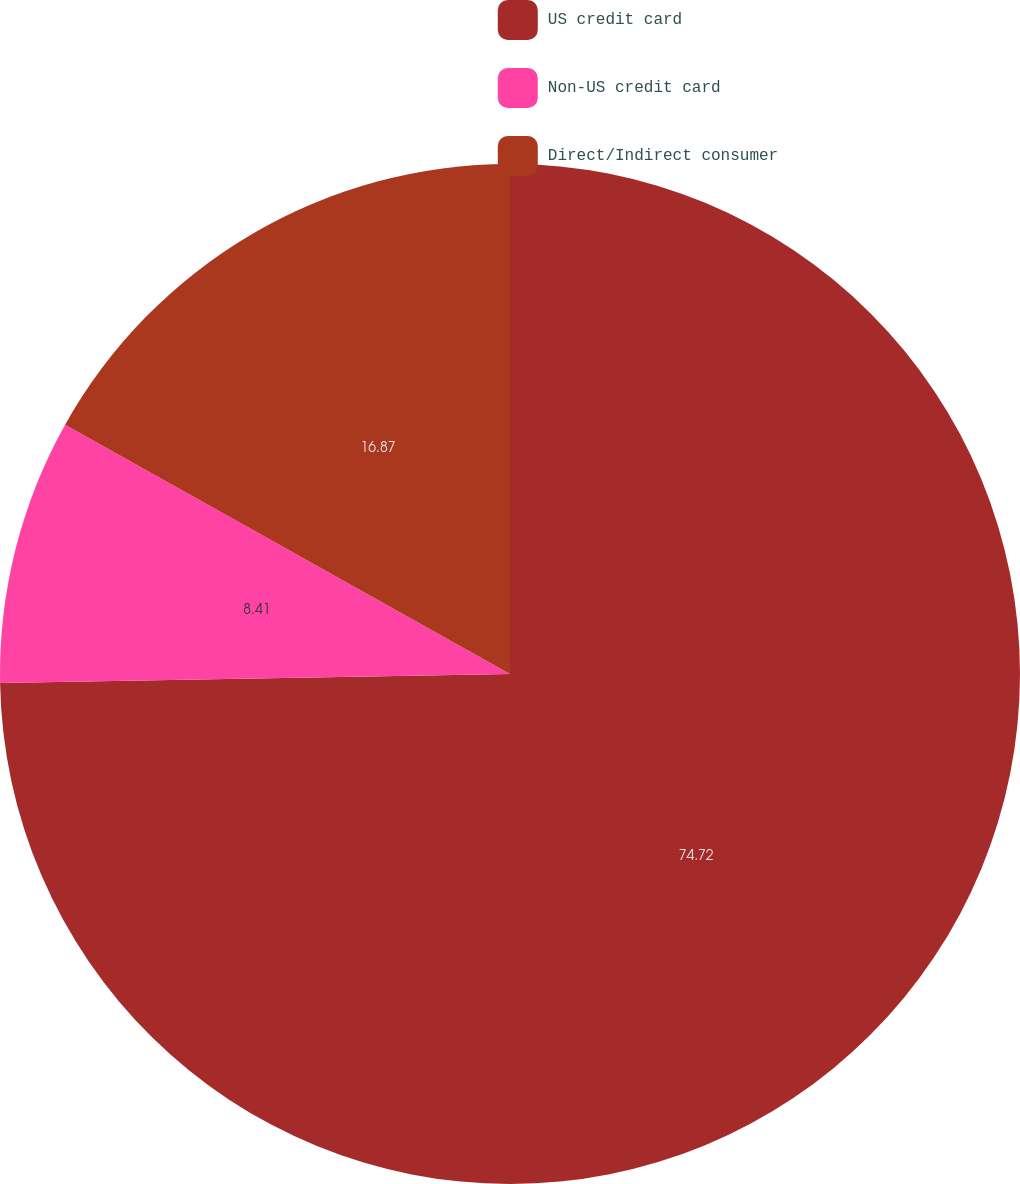Convert chart to OTSL. <chart><loc_0><loc_0><loc_500><loc_500><pie_chart><fcel>US credit card<fcel>Non-US credit card<fcel>Direct/Indirect consumer<nl><fcel>74.72%<fcel>8.41%<fcel>16.87%<nl></chart> 